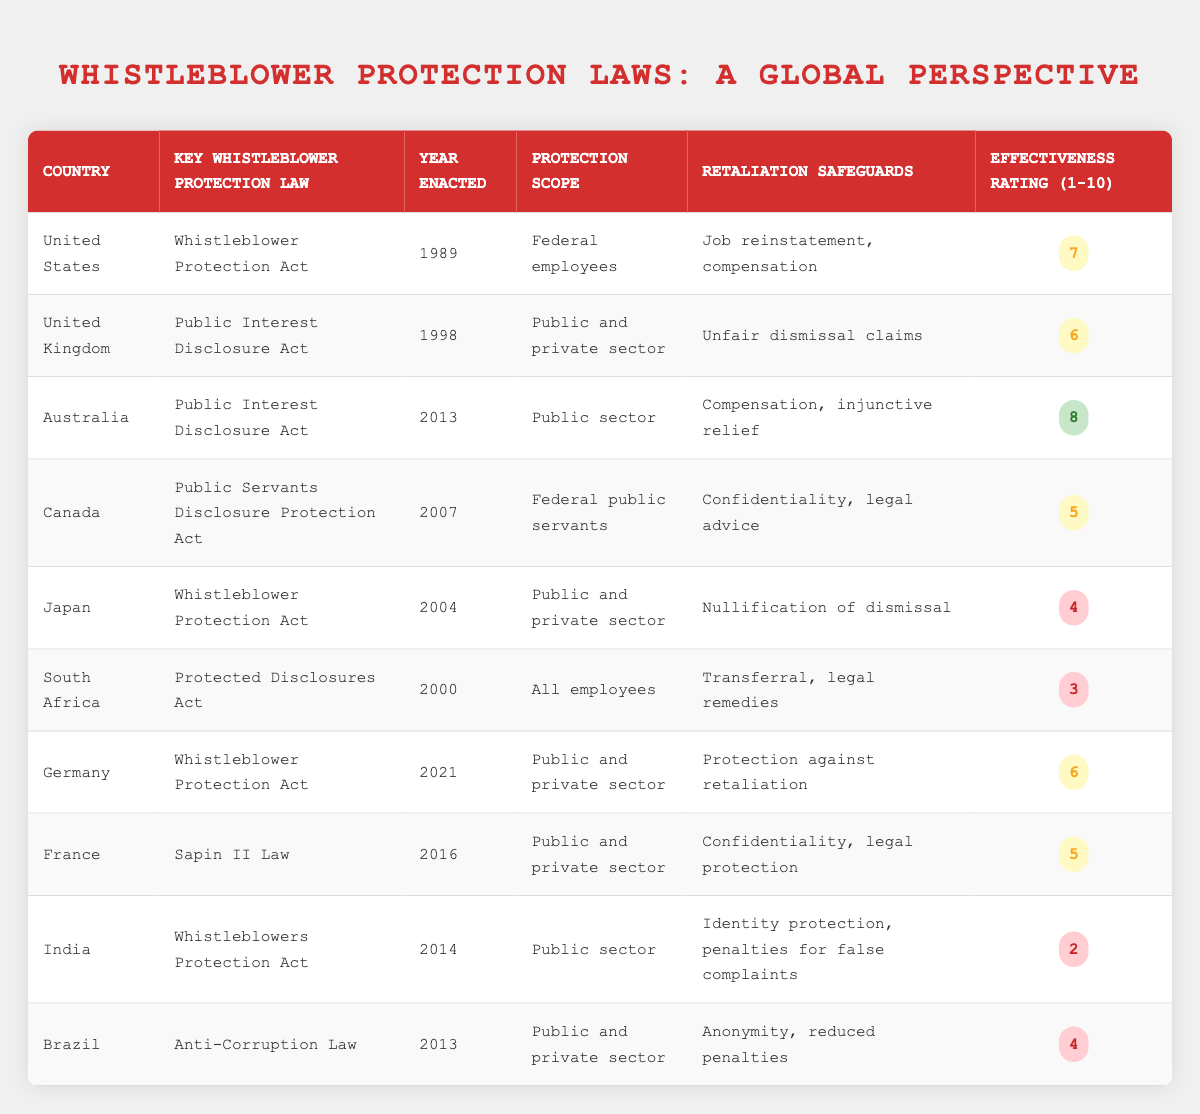What is the key whistleblower protection law in Australia? The table indicates that Australia's key whistleblower protection law is the "Public Interest Disclosure Act."
Answer: Public Interest Disclosure Act Which country has the highest effectiveness rating for whistleblower protection laws? According to the effectiveness ratings in the table, Australia has the highest rating of 8 out of 10.
Answer: Australia Is it true that India has a higher effectiveness rating than South Africa? The table shows that India has an effectiveness rating of 2 while South Africa has a rating of 3. Therefore, the statement is false.
Answer: No What is the average effectiveness rating across all listed countries? To find the average, we sum the effectiveness ratings: 7 + 6 + 8 + 5 + 4 + 3 + 6 + 5 + 2 + 4 = 50. There are 10 countries, so the average is 50 / 10 = 5.
Answer: 5 Which countries allow protection for both public and private sector whistleblowers? From the table, the countries allowing protection for both public and private sectors are the United Kingdom, Japan, Germany, and France.
Answer: United Kingdom, Japan, Germany, France 